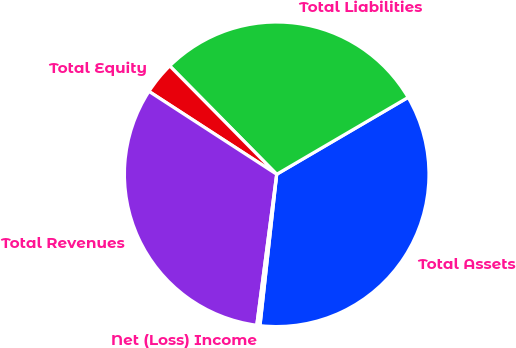<chart> <loc_0><loc_0><loc_500><loc_500><pie_chart><fcel>Total Assets<fcel>Total Liabilities<fcel>Total Equity<fcel>Total Revenues<fcel>Net (Loss) Income<nl><fcel>35.17%<fcel>28.97%<fcel>3.44%<fcel>32.07%<fcel>0.34%<nl></chart> 